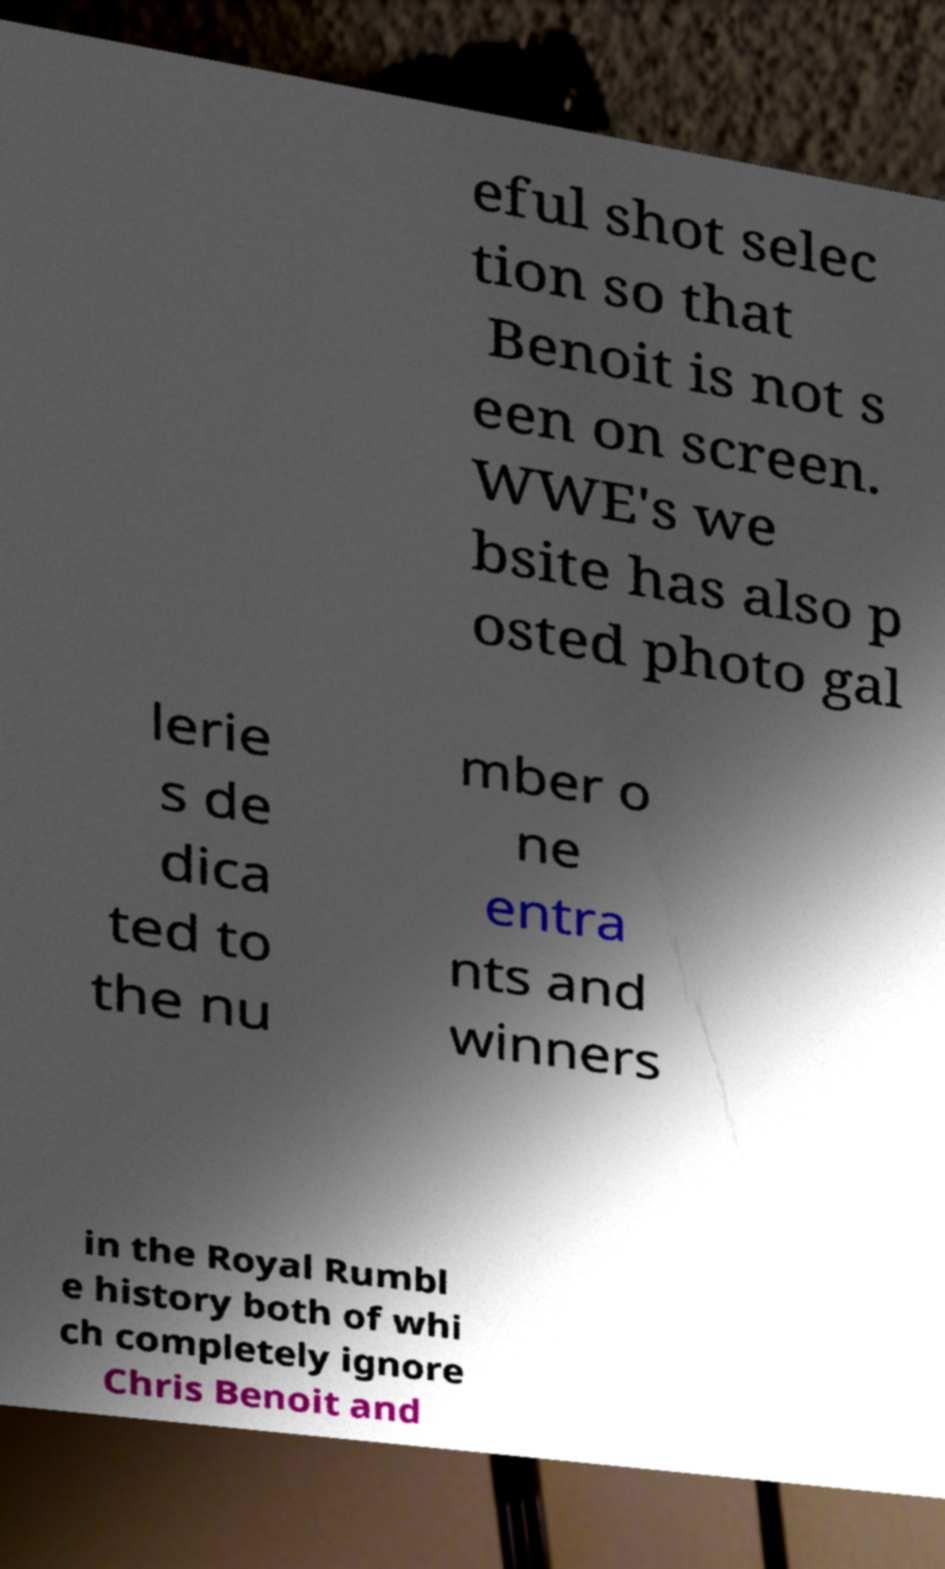For documentation purposes, I need the text within this image transcribed. Could you provide that? eful shot selec tion so that Benoit is not s een on screen. WWE's we bsite has also p osted photo gal lerie s de dica ted to the nu mber o ne entra nts and winners in the Royal Rumbl e history both of whi ch completely ignore Chris Benoit and 